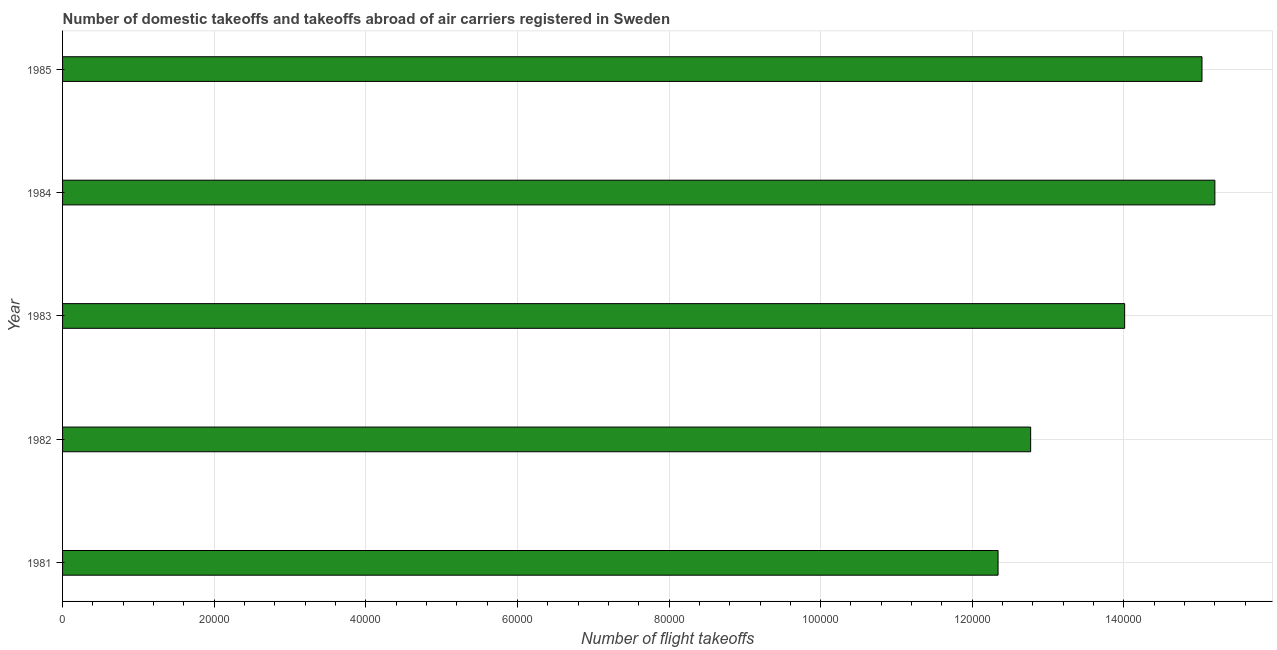What is the title of the graph?
Your answer should be compact. Number of domestic takeoffs and takeoffs abroad of air carriers registered in Sweden. What is the label or title of the X-axis?
Provide a short and direct response. Number of flight takeoffs. What is the number of flight takeoffs in 1981?
Your answer should be compact. 1.23e+05. Across all years, what is the maximum number of flight takeoffs?
Your response must be concise. 1.52e+05. Across all years, what is the minimum number of flight takeoffs?
Keep it short and to the point. 1.23e+05. In which year was the number of flight takeoffs maximum?
Ensure brevity in your answer.  1984. What is the sum of the number of flight takeoffs?
Provide a short and direct response. 6.94e+05. What is the difference between the number of flight takeoffs in 1981 and 1982?
Your response must be concise. -4300. What is the average number of flight takeoffs per year?
Ensure brevity in your answer.  1.39e+05. What is the median number of flight takeoffs?
Your answer should be compact. 1.40e+05. In how many years, is the number of flight takeoffs greater than 20000 ?
Give a very brief answer. 5. Do a majority of the years between 1984 and 1983 (inclusive) have number of flight takeoffs greater than 132000 ?
Offer a terse response. No. What is the ratio of the number of flight takeoffs in 1981 to that in 1984?
Offer a terse response. 0.81. Is the difference between the number of flight takeoffs in 1981 and 1984 greater than the difference between any two years?
Offer a terse response. Yes. What is the difference between the highest and the second highest number of flight takeoffs?
Keep it short and to the point. 1700. What is the difference between the highest and the lowest number of flight takeoffs?
Offer a terse response. 2.86e+04. In how many years, is the number of flight takeoffs greater than the average number of flight takeoffs taken over all years?
Your answer should be very brief. 3. Are all the bars in the graph horizontal?
Offer a terse response. Yes. How many years are there in the graph?
Your answer should be compact. 5. What is the Number of flight takeoffs of 1981?
Provide a succinct answer. 1.23e+05. What is the Number of flight takeoffs of 1982?
Make the answer very short. 1.28e+05. What is the Number of flight takeoffs in 1983?
Ensure brevity in your answer.  1.40e+05. What is the Number of flight takeoffs in 1984?
Ensure brevity in your answer.  1.52e+05. What is the Number of flight takeoffs in 1985?
Provide a succinct answer. 1.50e+05. What is the difference between the Number of flight takeoffs in 1981 and 1982?
Make the answer very short. -4300. What is the difference between the Number of flight takeoffs in 1981 and 1983?
Provide a short and direct response. -1.67e+04. What is the difference between the Number of flight takeoffs in 1981 and 1984?
Your answer should be compact. -2.86e+04. What is the difference between the Number of flight takeoffs in 1981 and 1985?
Your answer should be compact. -2.69e+04. What is the difference between the Number of flight takeoffs in 1982 and 1983?
Offer a terse response. -1.24e+04. What is the difference between the Number of flight takeoffs in 1982 and 1984?
Your answer should be very brief. -2.43e+04. What is the difference between the Number of flight takeoffs in 1982 and 1985?
Ensure brevity in your answer.  -2.26e+04. What is the difference between the Number of flight takeoffs in 1983 and 1984?
Make the answer very short. -1.19e+04. What is the difference between the Number of flight takeoffs in 1983 and 1985?
Your answer should be very brief. -1.02e+04. What is the difference between the Number of flight takeoffs in 1984 and 1985?
Offer a very short reply. 1700. What is the ratio of the Number of flight takeoffs in 1981 to that in 1982?
Your response must be concise. 0.97. What is the ratio of the Number of flight takeoffs in 1981 to that in 1983?
Offer a very short reply. 0.88. What is the ratio of the Number of flight takeoffs in 1981 to that in 1984?
Your response must be concise. 0.81. What is the ratio of the Number of flight takeoffs in 1981 to that in 1985?
Offer a very short reply. 0.82. What is the ratio of the Number of flight takeoffs in 1982 to that in 1983?
Offer a very short reply. 0.91. What is the ratio of the Number of flight takeoffs in 1982 to that in 1984?
Your response must be concise. 0.84. What is the ratio of the Number of flight takeoffs in 1982 to that in 1985?
Offer a very short reply. 0.85. What is the ratio of the Number of flight takeoffs in 1983 to that in 1984?
Your answer should be very brief. 0.92. What is the ratio of the Number of flight takeoffs in 1983 to that in 1985?
Offer a very short reply. 0.93. 